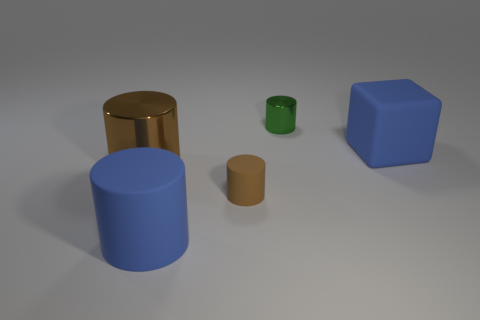Is the color of the large metallic cylinder the same as the metal cylinder that is behind the blue rubber block?
Make the answer very short. No. There is a metallic cylinder in front of the cube; how many blue cubes are on the right side of it?
Your answer should be very brief. 1. Is there anything else that is the same material as the green thing?
Keep it short and to the point. Yes. What material is the large blue cylinder that is in front of the cylinder that is behind the matte object behind the tiny rubber thing?
Offer a terse response. Rubber. There is a object that is both in front of the big brown object and left of the tiny brown thing; what material is it?
Keep it short and to the point. Rubber. How many large brown things are the same shape as the tiny metal object?
Your response must be concise. 1. There is a blue thing on the left side of the blue matte object behind the large blue cylinder; how big is it?
Make the answer very short. Large. There is a large rubber cylinder left of the brown rubber thing; is it the same color as the shiny cylinder that is in front of the small metallic object?
Your answer should be compact. No. There is a metallic cylinder in front of the large blue matte object behind the small rubber thing; how many small objects are on the right side of it?
Your response must be concise. 2. How many large things are right of the small green thing and in front of the big brown object?
Offer a very short reply. 0. 